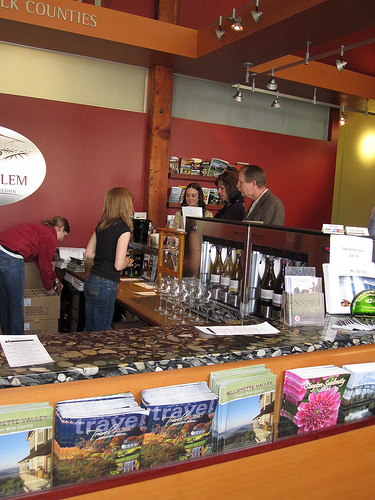<image>
Is there a magazine on the counter? No. The magazine is not positioned on the counter. They may be near each other, but the magazine is not supported by or resting on top of the counter. 